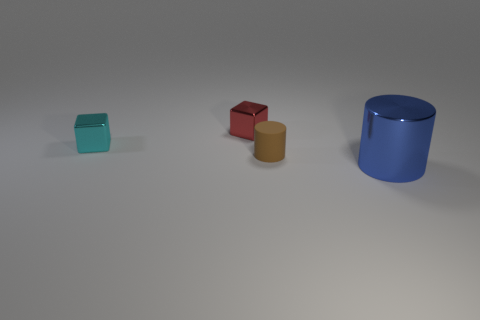Add 4 large blue things. How many objects exist? 8 Subtract 0 blue blocks. How many objects are left? 4 Subtract all small blue spheres. Subtract all blue cylinders. How many objects are left? 3 Add 1 big blue cylinders. How many big blue cylinders are left? 2 Add 4 brown cubes. How many brown cubes exist? 4 